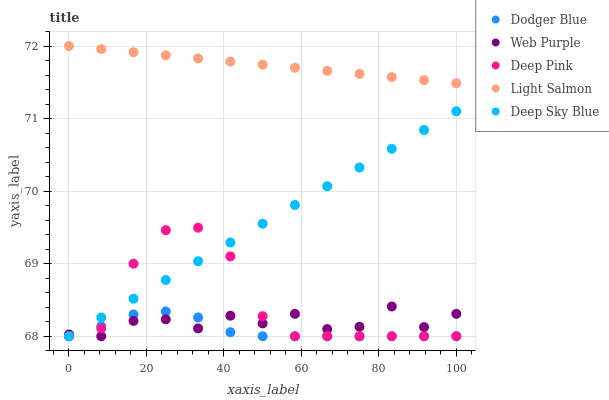Does Dodger Blue have the minimum area under the curve?
Answer yes or no. Yes. Does Light Salmon have the maximum area under the curve?
Answer yes or no. Yes. Does Deep Pink have the minimum area under the curve?
Answer yes or no. No. Does Deep Pink have the maximum area under the curve?
Answer yes or no. No. Is Deep Sky Blue the smoothest?
Answer yes or no. Yes. Is Deep Pink the roughest?
Answer yes or no. Yes. Is Dodger Blue the smoothest?
Answer yes or no. No. Is Dodger Blue the roughest?
Answer yes or no. No. Does Web Purple have the lowest value?
Answer yes or no. Yes. Does Light Salmon have the lowest value?
Answer yes or no. No. Does Light Salmon have the highest value?
Answer yes or no. Yes. Does Deep Pink have the highest value?
Answer yes or no. No. Is Web Purple less than Light Salmon?
Answer yes or no. Yes. Is Light Salmon greater than Dodger Blue?
Answer yes or no. Yes. Does Dodger Blue intersect Web Purple?
Answer yes or no. Yes. Is Dodger Blue less than Web Purple?
Answer yes or no. No. Is Dodger Blue greater than Web Purple?
Answer yes or no. No. Does Web Purple intersect Light Salmon?
Answer yes or no. No. 